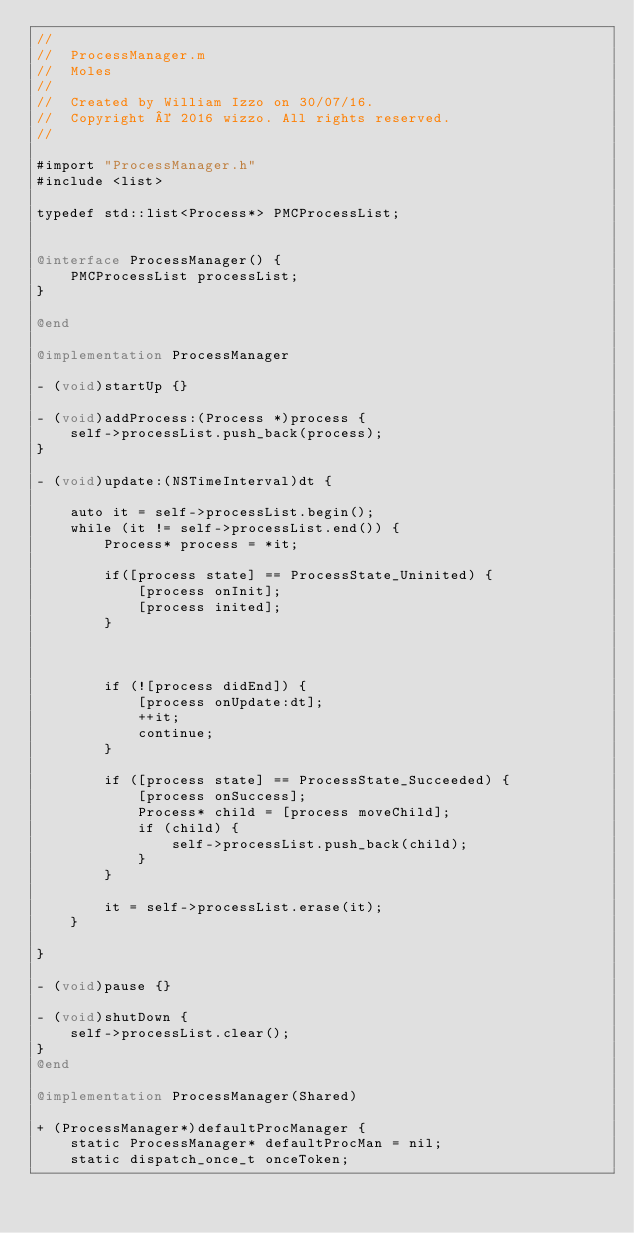<code> <loc_0><loc_0><loc_500><loc_500><_ObjectiveC_>//
//  ProcessManager.m
//  Moles
//
//  Created by William Izzo on 30/07/16.
//  Copyright © 2016 wizzo. All rights reserved.
//

#import "ProcessManager.h"
#include <list>

typedef std::list<Process*> PMCProcessList;


@interface ProcessManager() {
    PMCProcessList processList;
}

@end

@implementation ProcessManager

- (void)startUp {}

- (void)addProcess:(Process *)process {
    self->processList.push_back(process);
}

- (void)update:(NSTimeInterval)dt {
    
    auto it = self->processList.begin();
    while (it != self->processList.end()) {
        Process* process = *it;
        
        if([process state] == ProcessState_Uninited) {
            [process onInit];
            [process inited];
        }
        
        
        
        if (![process didEnd]) {
            [process onUpdate:dt];
            ++it;
            continue;
        }
        
        if ([process state] == ProcessState_Succeeded) {
            [process onSuccess];
            Process* child = [process moveChild];
            if (child) {
                self->processList.push_back(child);
            }
        }
        
        it = self->processList.erase(it);
    }
    
}

- (void)pause {}

- (void)shutDown {
    self->processList.clear();
}
@end

@implementation ProcessManager(Shared)

+ (ProcessManager*)defaultProcManager {
    static ProcessManager* defaultProcMan = nil;
    static dispatch_once_t onceToken;</code> 